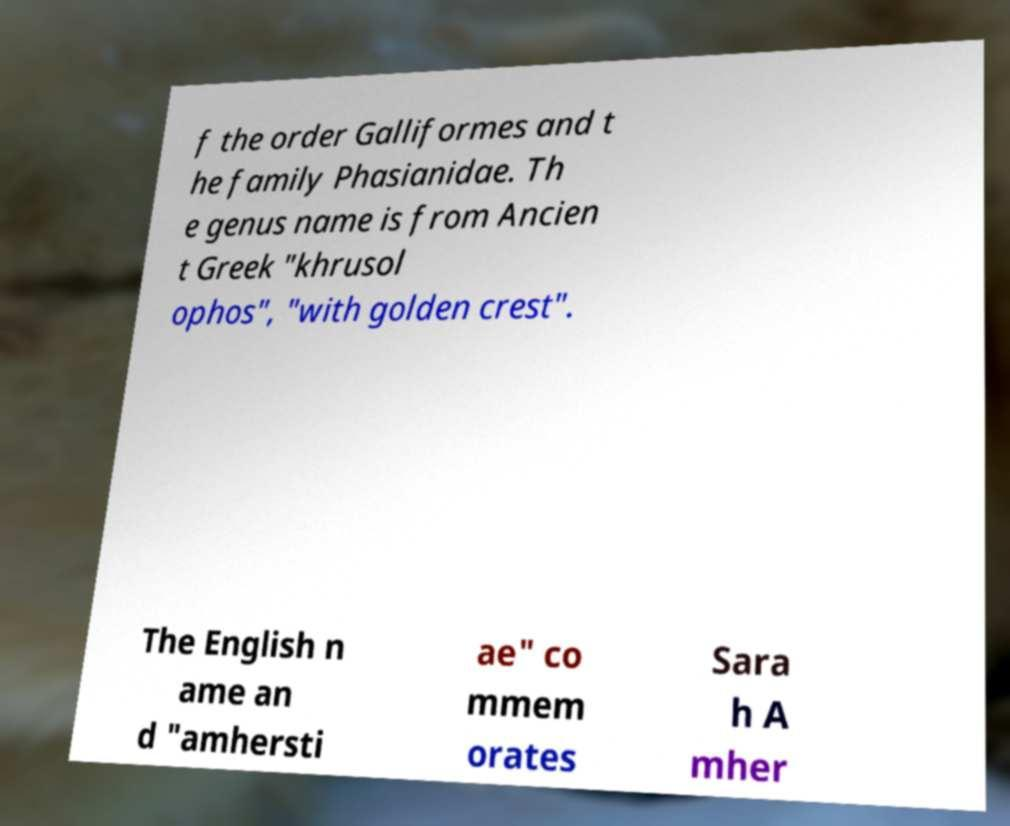Please identify and transcribe the text found in this image. f the order Galliformes and t he family Phasianidae. Th e genus name is from Ancien t Greek "khrusol ophos", "with golden crest". The English n ame an d "amhersti ae" co mmem orates Sara h A mher 